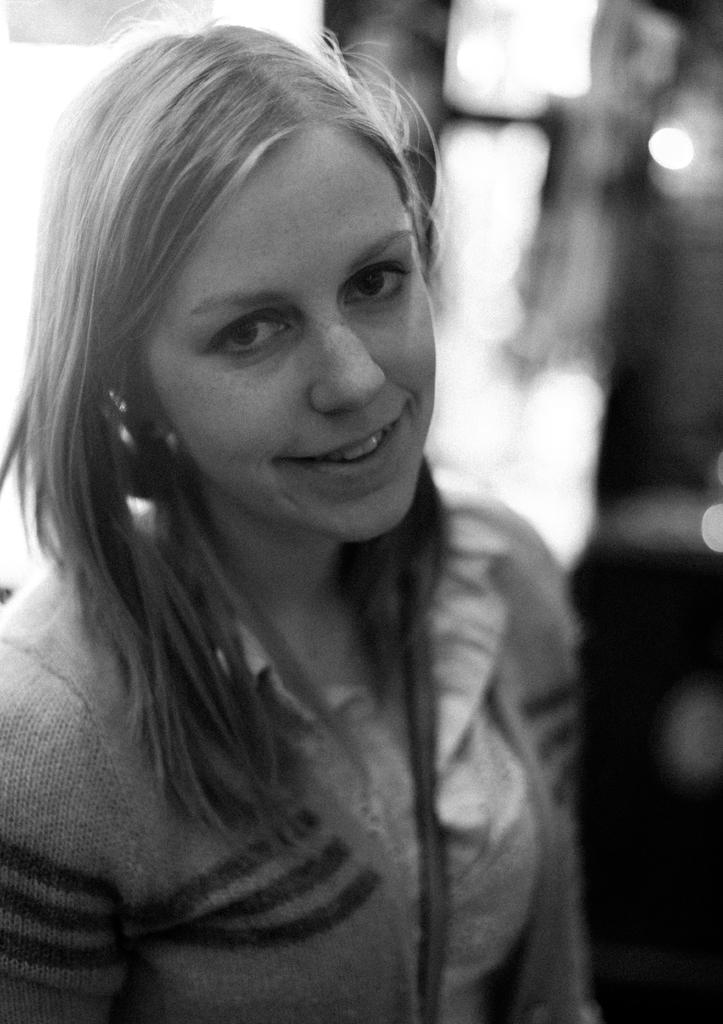What is the color scheme of the image? The image is black and white. Who is present in the image? There is a woman in the image. What is the woman's facial expression? The woman is smiling. Can you describe the background of the image? The background of the image is blurred. What type of footwear is the woman wearing in the image? There is no information about the woman's footwear in the image, as it is black and white and the focus is on her facial expression. What punishment is the woman receiving in the image? There is no indication of any punishment in the image; the woman is simply smiling. 